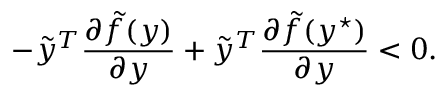Convert formula to latex. <formula><loc_0><loc_0><loc_500><loc_500>- \tilde { y } ^ { T } \frac { \partial \tilde { f } ( y ) } { \partial y } + \tilde { y } ^ { T } \frac { \partial \tilde { f } ( y ^ { ^ { * } } ) } { \partial y } < 0 .</formula> 